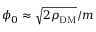Convert formula to latex. <formula><loc_0><loc_0><loc_500><loc_500>\phi _ { 0 } \approx \sqrt { 2 \rho _ { D M } } / m</formula> 